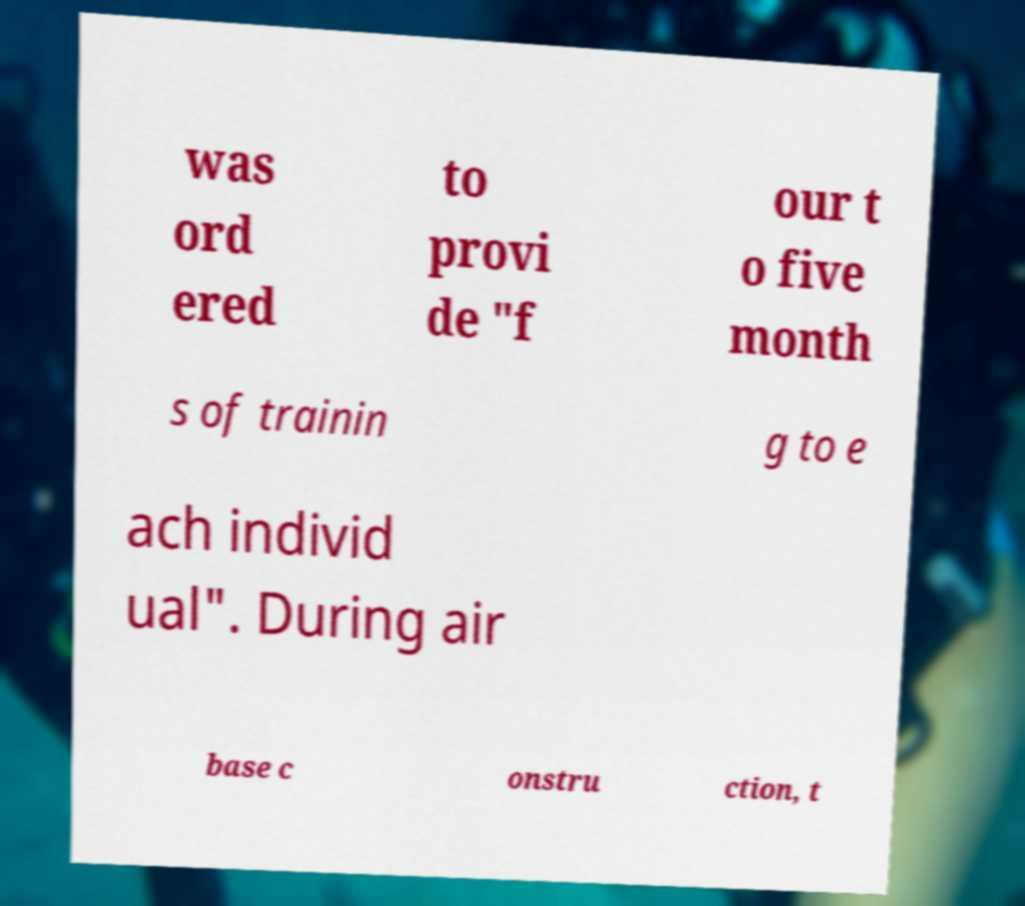For documentation purposes, I need the text within this image transcribed. Could you provide that? was ord ered to provi de "f our t o five month s of trainin g to e ach individ ual". During air base c onstru ction, t 